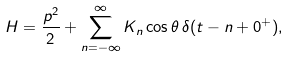<formula> <loc_0><loc_0><loc_500><loc_500>H = \frac { p ^ { 2 } } { 2 } + \sum _ { n = - \infty } ^ { \infty } K _ { n } \cos \theta \, \delta ( t - n + 0 ^ { + } ) ,</formula> 